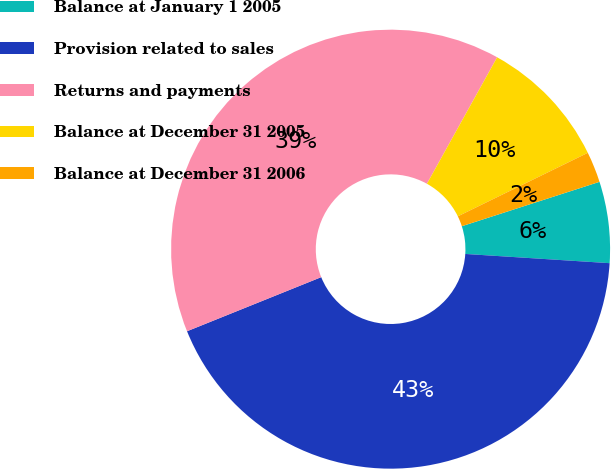Convert chart. <chart><loc_0><loc_0><loc_500><loc_500><pie_chart><fcel>Balance at January 1 2005<fcel>Provision related to sales<fcel>Returns and payments<fcel>Balance at December 31 2005<fcel>Balance at December 31 2006<nl><fcel>5.98%<fcel>42.89%<fcel>39.17%<fcel>9.7%<fcel>2.27%<nl></chart> 